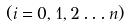<formula> <loc_0><loc_0><loc_500><loc_500>( i = 0 , 1 , 2 \dots n )</formula> 